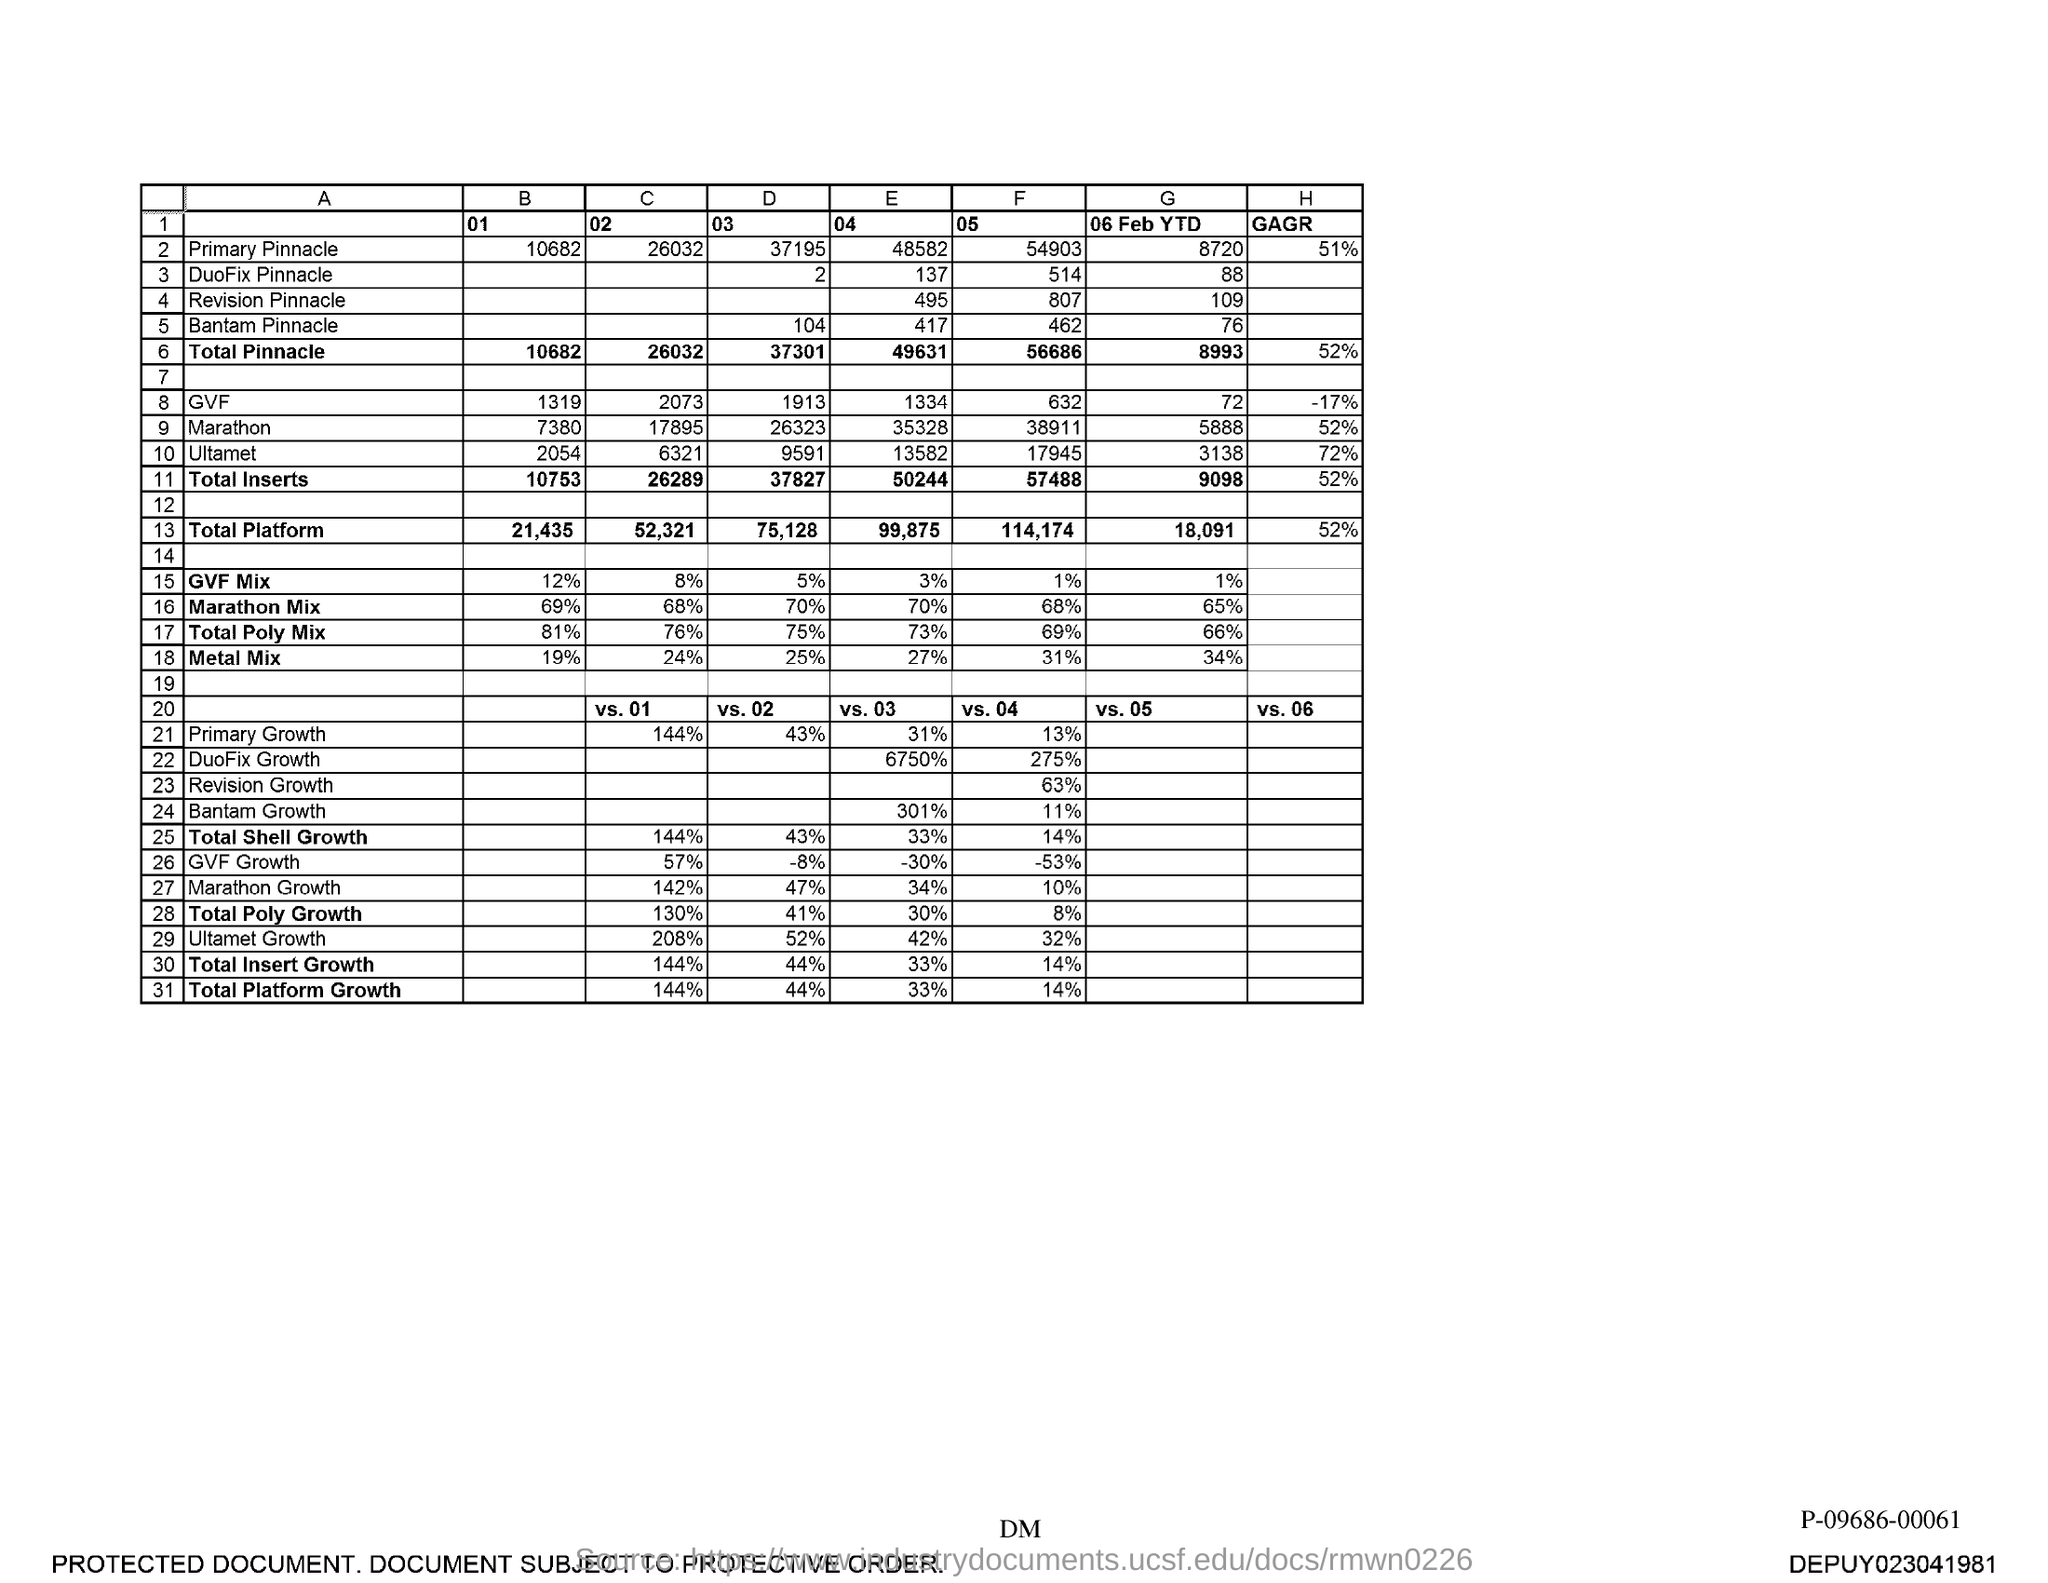Outline some significant characteristics in this image. What is the E04 value for Duofix Pinnacle? 137. What is the value for the primary pinnacle at 54903? What is the value of the 'E' for the primary pinnacle at coordinates 48582? What is the value for Total Pinnacle, specifically the 'B' value labeled as "01"? What is the value of the letter 'F' followed by the number '05' for the Revision Pinnacle model 807? 